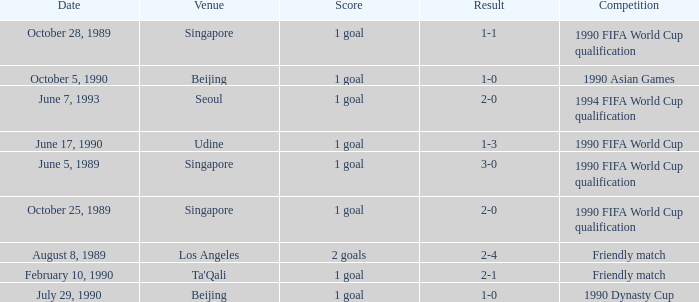What was the score of the match with a 3-0 result? 1 goal. 